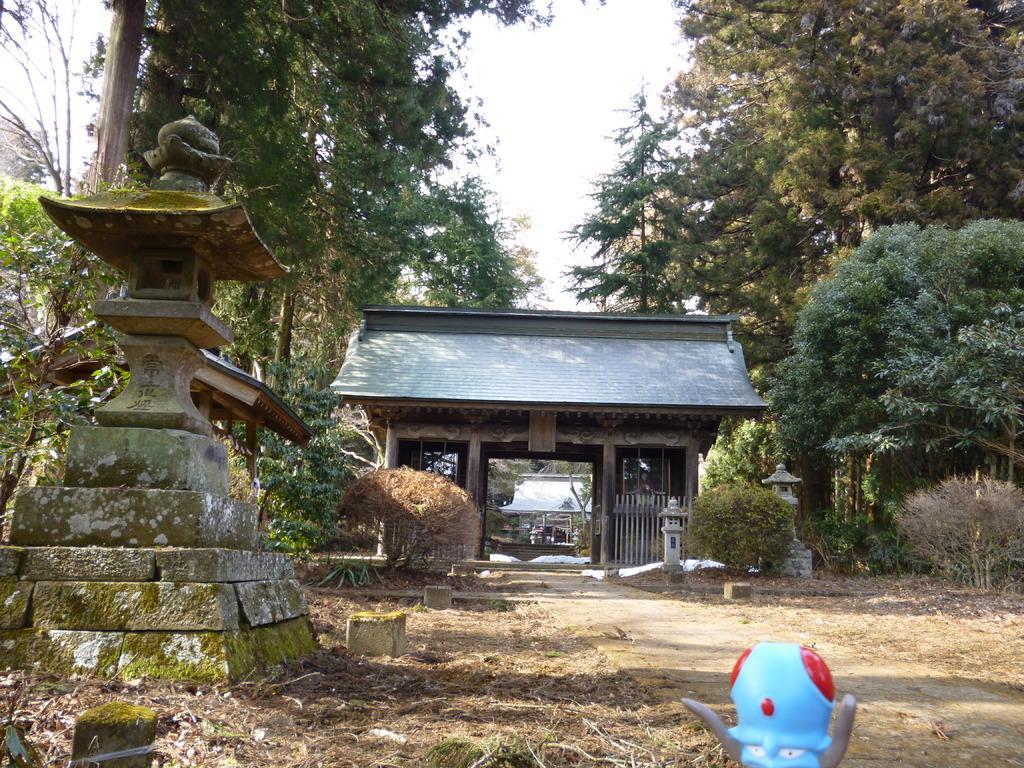Could you give a brief overview of what you see in this image? In this picture we can the concrete pillar in the front. Behind there is a arch gate with roof tiles. On both the side we can see the some trees. 